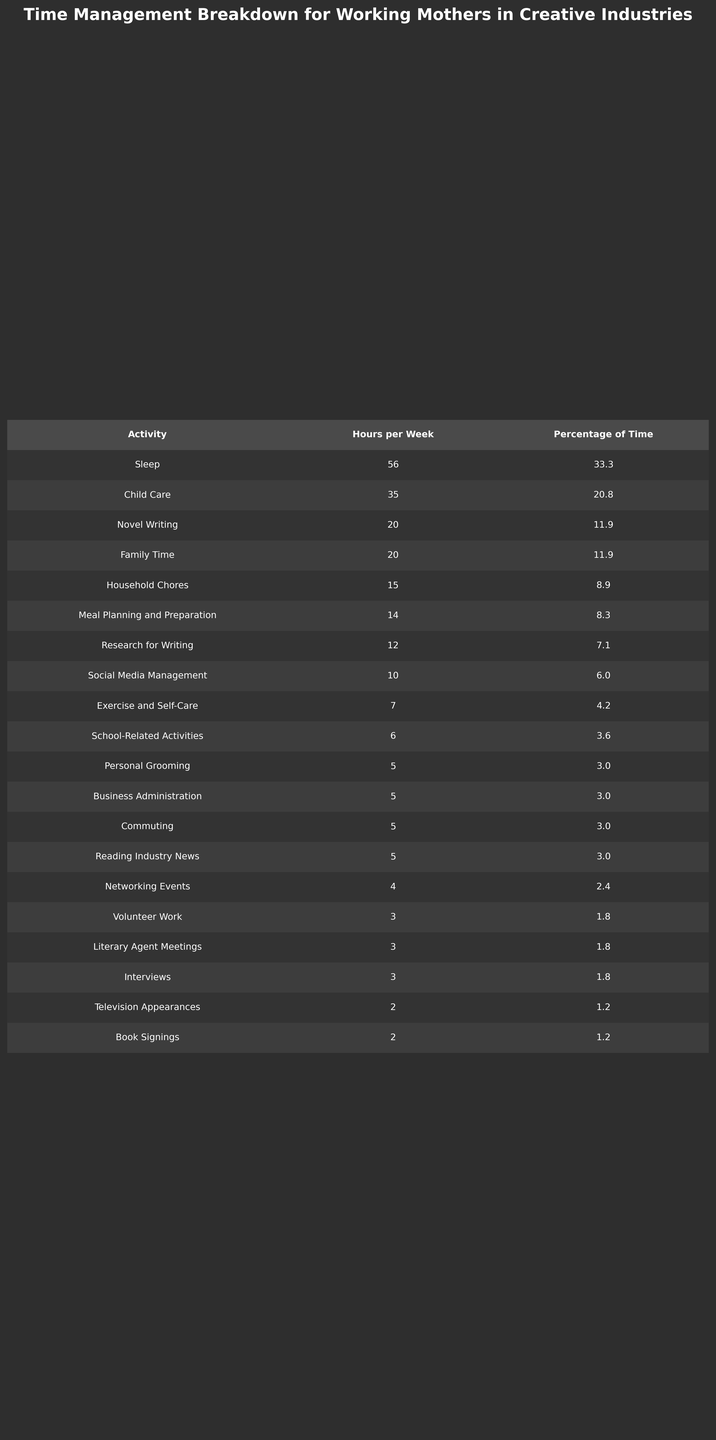What activity takes the most hours per week for working mothers in creative industries? The table shows that Child Care is listed with 35 hours per week, which is the highest value.
Answer: Child Care What is the total percentage of time spent on Novel Writing and Research for Writing? The percentage for Novel Writing is 11.9% and for Research for Writing is 7.1%. Adding these gives us 11.9 + 7.1 = 19.0%.
Answer: 19.0% Is there more time spent on literature-related activities (Novel Writing, Research for Writing, and Literary Agent Meetings) than on Household Chores? The sum of the percentages for literature-related activities is 11.9 + 7.1 + 1.8 = 20.8%. The percentage for Household Chores is 8.9%, which is less. Thus, the statement is true.
Answer: Yes What is the average time spent on Sleep and Family Time combined? Sleep is 56 hours and Family Time is 20 hours. To get the average, we sum these (56 + 20 = 76 hours) and divide by 2 (76 / 2 = 38).
Answer: 38 Which activity has the lowest percentage of time and what is its percentage? The activity with the lowest percentage is Book Signings with 1.2%.
Answer: Book Signings, 1.2% If a working mother allocates 20% of her week to Child Care, how many hours would that be based on a typical 168-hour week? To find this, we calculate 20% of 168 hours, which is (0.20 * 168 = 33.6 hours). Since the table shows 35 hours, which is close, we can assert that she spends slightly more than 20%.
Answer: 33.6 hours How much more time, in hours, is spent on Exercise and Self-Care compared to Interviews? Exercise and Self-Care takes 7 hours, while Interviews takes 3 hours. The difference is 7 - 3 = 4 hours.
Answer: 4 hours Which two activities combine to make up approximately 24% of the total time? If we add Child Care (20.8%) and Exercise and Self-Care (4.2%), we get 20.8 + 4.2 = 25%, which is close to 24%.
Answer: Child Care and Exercise and Self-Care Is the time spent on Networking Events more than the time spent on Reading Industry News? Networking Events has 4 hours while Reading Industry News has 5 hours, so the statement is false.
Answer: No What is the total time spent on Social Media Management and Television Appearances? Social Media Management is 10 hours and Television Appearances is 2 hours. Adding these gives 10 + 2 = 12 hours.
Answer: 12 hours 